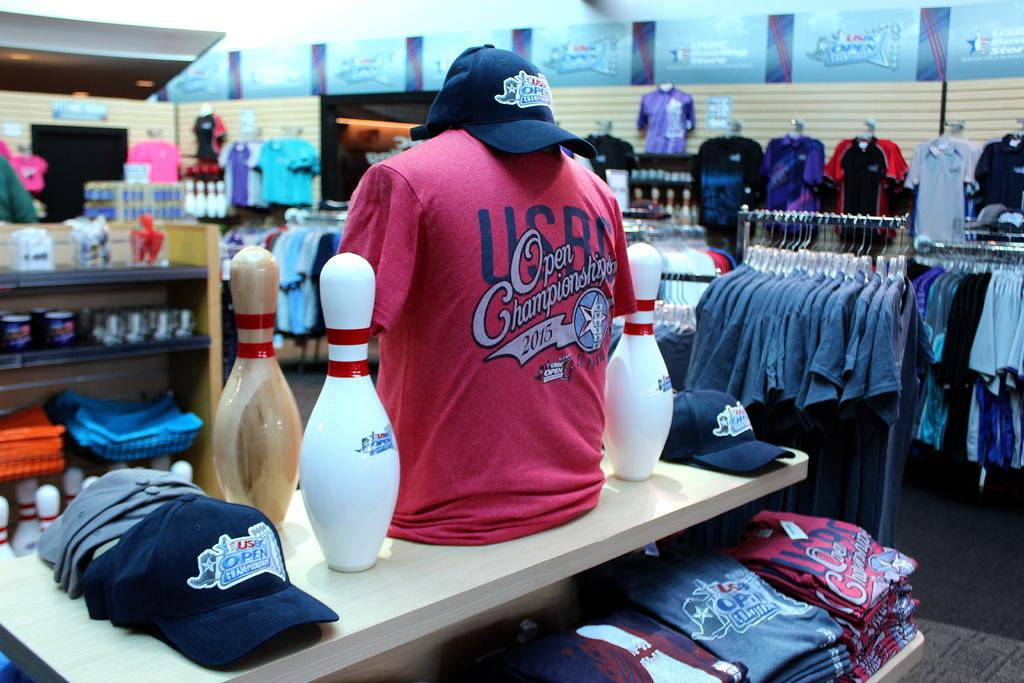Provide a one-sentence caption for the provided image. A clothing display with a shirt that says Open Championship 2015. 